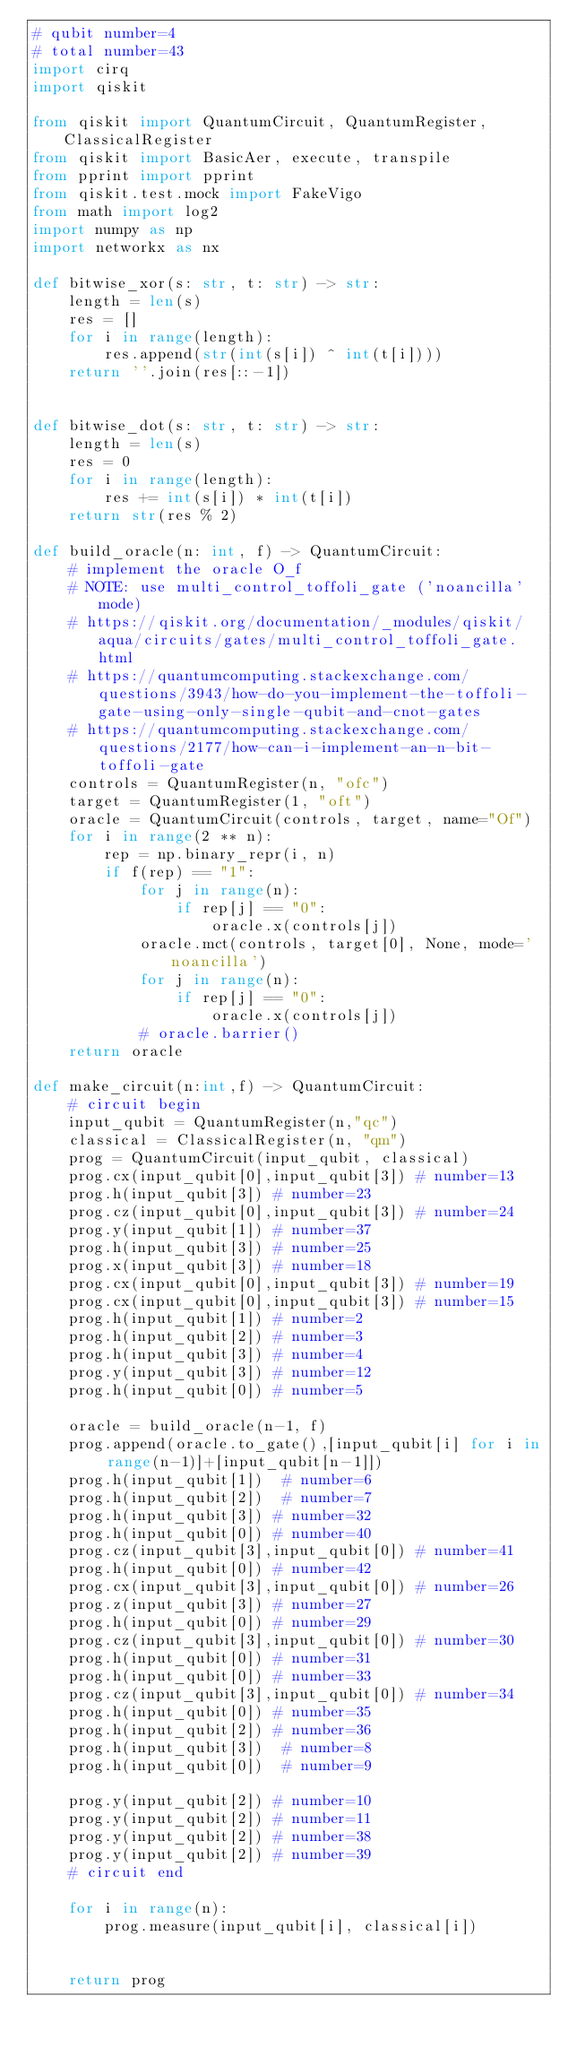Convert code to text. <code><loc_0><loc_0><loc_500><loc_500><_Python_># qubit number=4
# total number=43
import cirq
import qiskit

from qiskit import QuantumCircuit, QuantumRegister, ClassicalRegister
from qiskit import BasicAer, execute, transpile
from pprint import pprint
from qiskit.test.mock import FakeVigo
from math import log2
import numpy as np
import networkx as nx

def bitwise_xor(s: str, t: str) -> str:
    length = len(s)
    res = []
    for i in range(length):
        res.append(str(int(s[i]) ^ int(t[i])))
    return ''.join(res[::-1])


def bitwise_dot(s: str, t: str) -> str:
    length = len(s)
    res = 0
    for i in range(length):
        res += int(s[i]) * int(t[i])
    return str(res % 2)

def build_oracle(n: int, f) -> QuantumCircuit:
    # implement the oracle O_f
    # NOTE: use multi_control_toffoli_gate ('noancilla' mode)
    # https://qiskit.org/documentation/_modules/qiskit/aqua/circuits/gates/multi_control_toffoli_gate.html
    # https://quantumcomputing.stackexchange.com/questions/3943/how-do-you-implement-the-toffoli-gate-using-only-single-qubit-and-cnot-gates
    # https://quantumcomputing.stackexchange.com/questions/2177/how-can-i-implement-an-n-bit-toffoli-gate
    controls = QuantumRegister(n, "ofc")
    target = QuantumRegister(1, "oft")
    oracle = QuantumCircuit(controls, target, name="Of")
    for i in range(2 ** n):
        rep = np.binary_repr(i, n)
        if f(rep) == "1":
            for j in range(n):
                if rep[j] == "0":
                    oracle.x(controls[j])
            oracle.mct(controls, target[0], None, mode='noancilla')
            for j in range(n):
                if rep[j] == "0":
                    oracle.x(controls[j])
            # oracle.barrier()
    return oracle

def make_circuit(n:int,f) -> QuantumCircuit:
    # circuit begin
    input_qubit = QuantumRegister(n,"qc")
    classical = ClassicalRegister(n, "qm")
    prog = QuantumCircuit(input_qubit, classical)
    prog.cx(input_qubit[0],input_qubit[3]) # number=13
    prog.h(input_qubit[3]) # number=23
    prog.cz(input_qubit[0],input_qubit[3]) # number=24
    prog.y(input_qubit[1]) # number=37
    prog.h(input_qubit[3]) # number=25
    prog.x(input_qubit[3]) # number=18
    prog.cx(input_qubit[0],input_qubit[3]) # number=19
    prog.cx(input_qubit[0],input_qubit[3]) # number=15
    prog.h(input_qubit[1]) # number=2
    prog.h(input_qubit[2]) # number=3
    prog.h(input_qubit[3]) # number=4
    prog.y(input_qubit[3]) # number=12
    prog.h(input_qubit[0]) # number=5

    oracle = build_oracle(n-1, f)
    prog.append(oracle.to_gate(),[input_qubit[i] for i in range(n-1)]+[input_qubit[n-1]])
    prog.h(input_qubit[1])  # number=6
    prog.h(input_qubit[2])  # number=7
    prog.h(input_qubit[3]) # number=32
    prog.h(input_qubit[0]) # number=40
    prog.cz(input_qubit[3],input_qubit[0]) # number=41
    prog.h(input_qubit[0]) # number=42
    prog.cx(input_qubit[3],input_qubit[0]) # number=26
    prog.z(input_qubit[3]) # number=27
    prog.h(input_qubit[0]) # number=29
    prog.cz(input_qubit[3],input_qubit[0]) # number=30
    prog.h(input_qubit[0]) # number=31
    prog.h(input_qubit[0]) # number=33
    prog.cz(input_qubit[3],input_qubit[0]) # number=34
    prog.h(input_qubit[0]) # number=35
    prog.h(input_qubit[2]) # number=36
    prog.h(input_qubit[3])  # number=8
    prog.h(input_qubit[0])  # number=9

    prog.y(input_qubit[2]) # number=10
    prog.y(input_qubit[2]) # number=11
    prog.y(input_qubit[2]) # number=38
    prog.y(input_qubit[2]) # number=39
    # circuit end

    for i in range(n):
        prog.measure(input_qubit[i], classical[i])


    return prog


</code> 